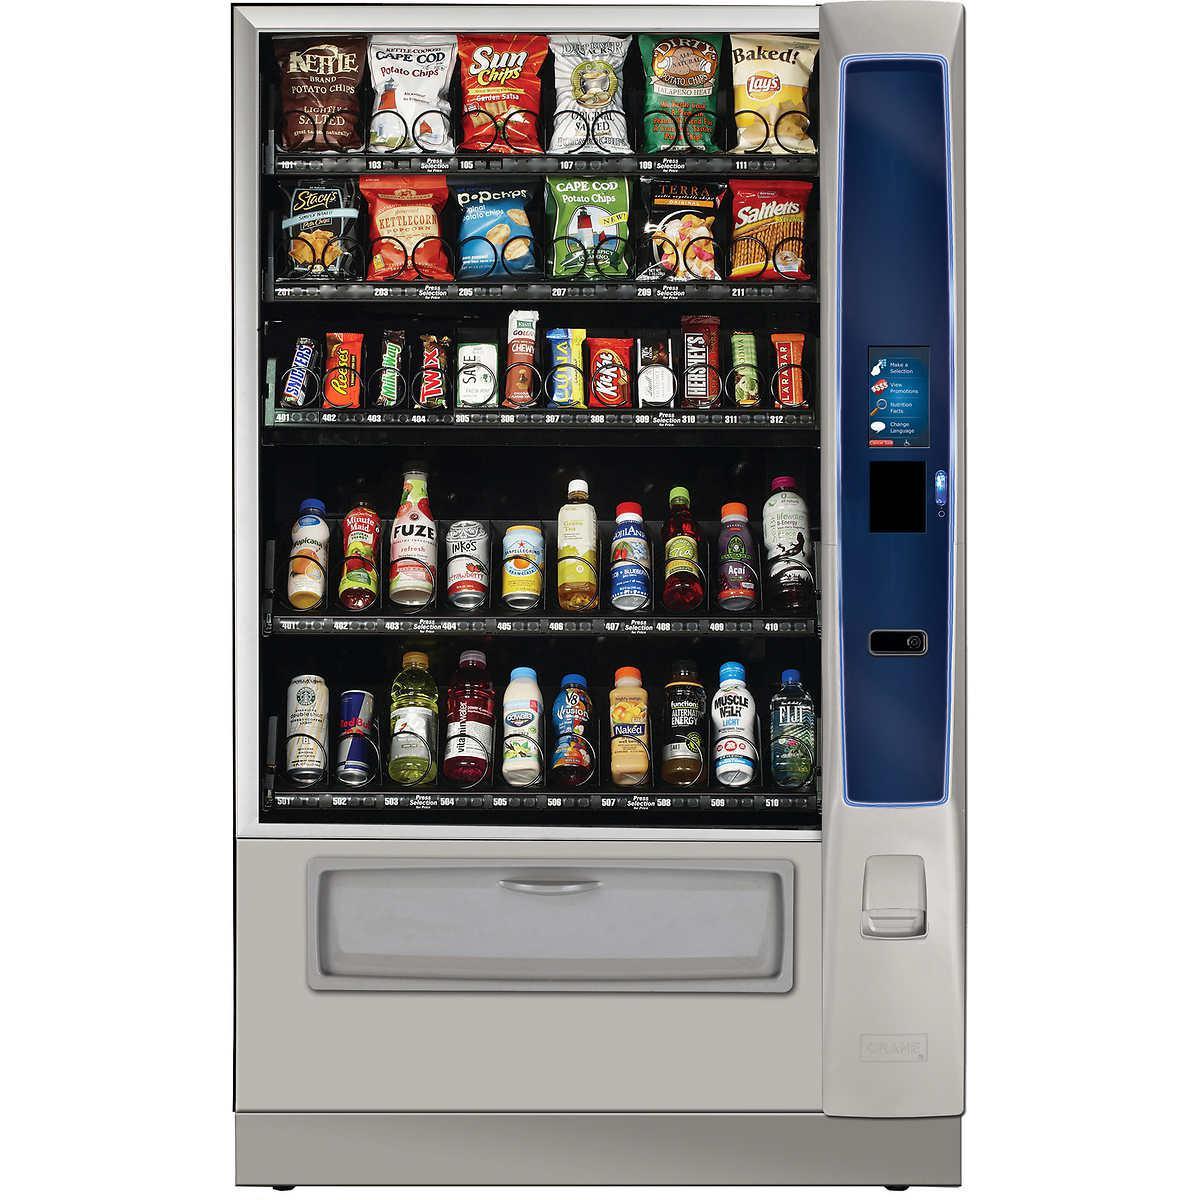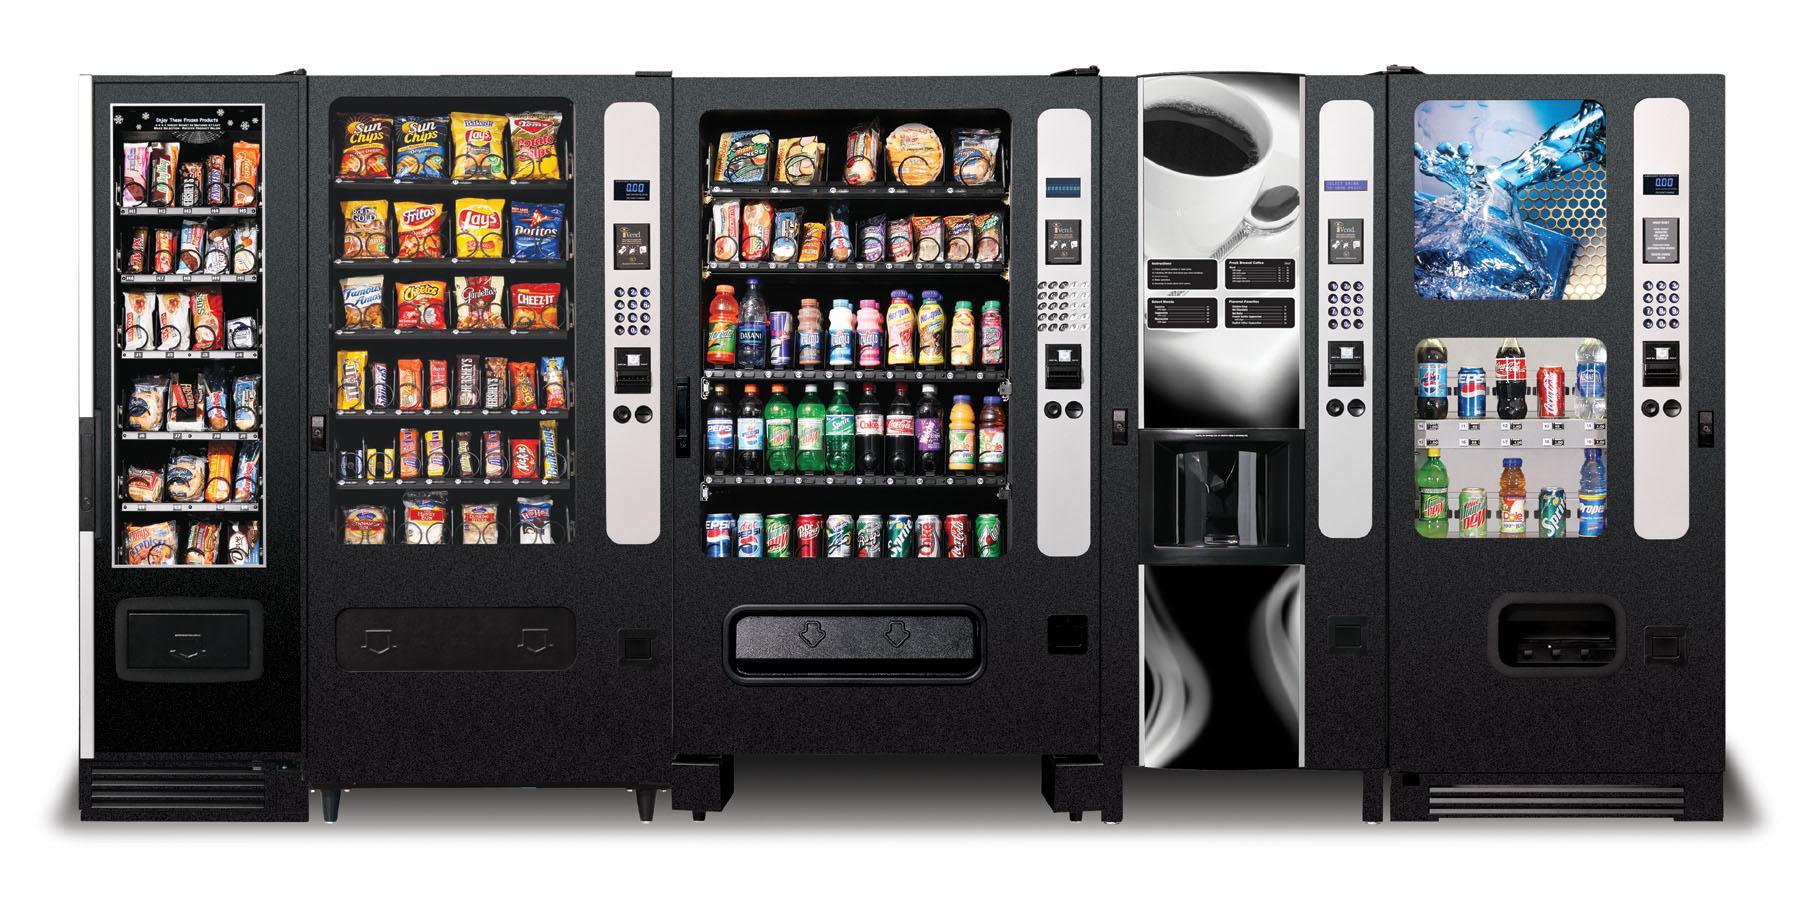The first image is the image on the left, the second image is the image on the right. Considering the images on both sides, is "Exactly two vending machines filled with snacks are shown." valid? Answer yes or no. No. 